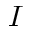<formula> <loc_0><loc_0><loc_500><loc_500>I</formula> 